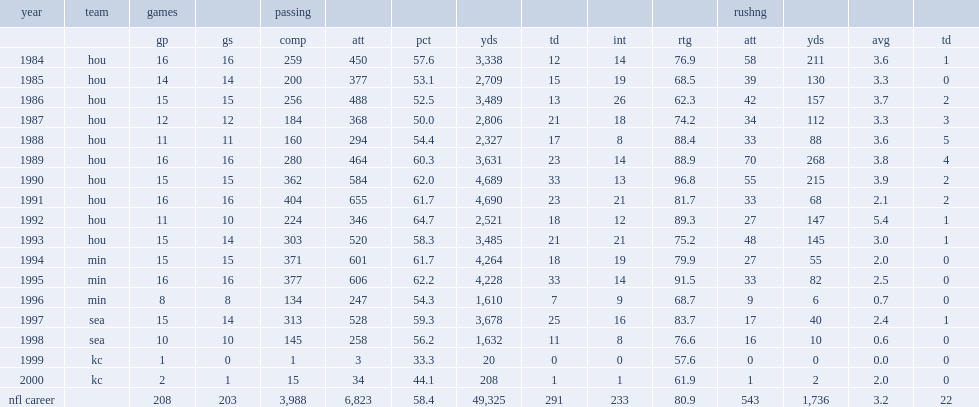Could you parse the entire table as a dict? {'header': ['year', 'team', 'games', '', 'passing', '', '', '', '', '', '', 'rushng', '', '', ''], 'rows': [['', '', 'gp', 'gs', 'comp', 'att', 'pct', 'yds', 'td', 'int', 'rtg', 'att', 'yds', 'avg', 'td'], ['1984', 'hou', '16', '16', '259', '450', '57.6', '3,338', '12', '14', '76.9', '58', '211', '3.6', '1'], ['1985', 'hou', '14', '14', '200', '377', '53.1', '2,709', '15', '19', '68.5', '39', '130', '3.3', '0'], ['1986', 'hou', '15', '15', '256', '488', '52.5', '3,489', '13', '26', '62.3', '42', '157', '3.7', '2'], ['1987', 'hou', '12', '12', '184', '368', '50.0', '2,806', '21', '18', '74.2', '34', '112', '3.3', '3'], ['1988', 'hou', '11', '11', '160', '294', '54.4', '2,327', '17', '8', '88.4', '33', '88', '3.6', '5'], ['1989', 'hou', '16', '16', '280', '464', '60.3', '3,631', '23', '14', '88.9', '70', '268', '3.8', '4'], ['1990', 'hou', '15', '15', '362', '584', '62.0', '4,689', '33', '13', '96.8', '55', '215', '3.9', '2'], ['1991', 'hou', '16', '16', '404', '655', '61.7', '4,690', '23', '21', '81.7', '33', '68', '2.1', '2'], ['1992', 'hou', '11', '10', '224', '346', '64.7', '2,521', '18', '12', '89.3', '27', '147', '5.4', '1'], ['1993', 'hou', '15', '14', '303', '520', '58.3', '3,485', '21', '21', '75.2', '48', '145', '3.0', '1'], ['1994', 'min', '15', '15', '371', '601', '61.7', '4,264', '18', '19', '79.9', '27', '55', '2.0', '0'], ['1995', 'min', '16', '16', '377', '606', '62.2', '4,228', '33', '14', '91.5', '33', '82', '2.5', '0'], ['1996', 'min', '8', '8', '134', '247', '54.3', '1,610', '7', '9', '68.7', '9', '6', '0.7', '0'], ['1997', 'sea', '15', '14', '313', '528', '59.3', '3,678', '25', '16', '83.7', '17', '40', '2.4', '1'], ['1998', 'sea', '10', '10', '145', '258', '56.2', '1,632', '11', '8', '76.6', '16', '10', '0.6', '0'], ['1999', 'kc', '1', '0', '1', '3', '33.3', '20', '0', '0', '57.6', '0', '0', '0.0', '0'], ['2000', 'kc', '2', '1', '15', '34', '44.1', '208', '1', '1', '61.9', '1', '2', '2.0', '0'], ['nfl career', '', '208', '203', '3,988', '6,823', '58.4', '49,325', '291', '233', '80.9', '543', '1,736', '3.2', '22']]} How many passing yards did warren moon have in 1991? 4690.0. 